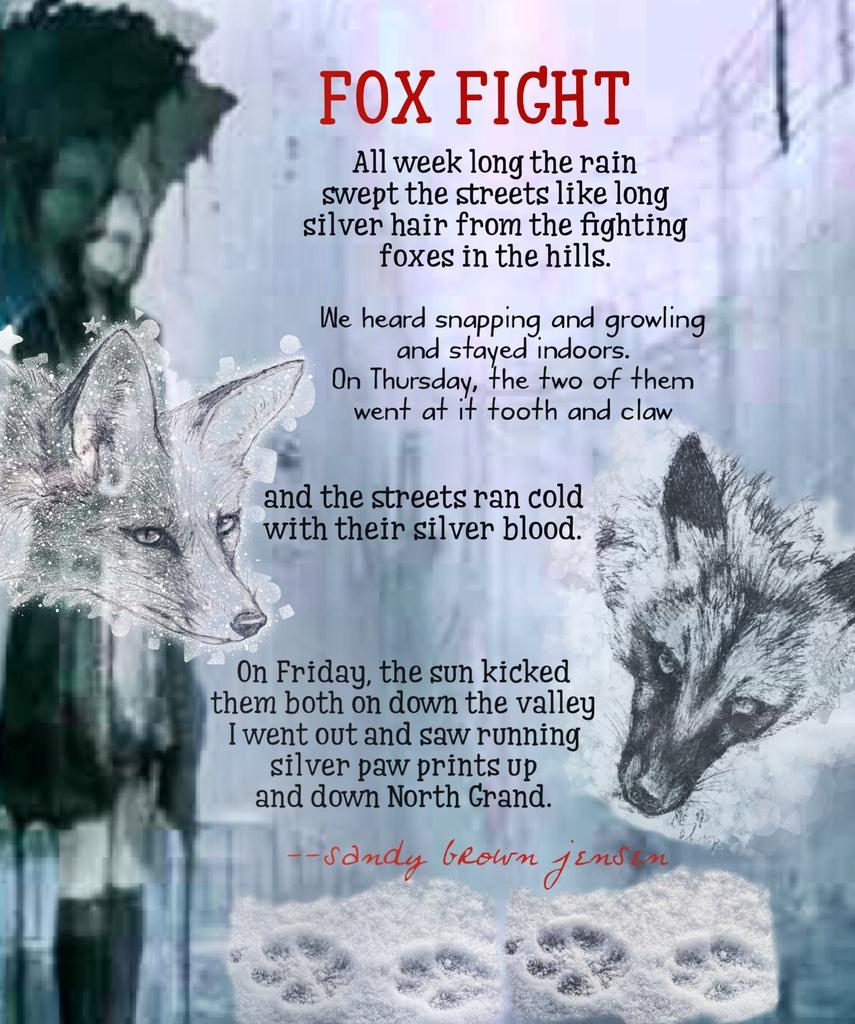What is featured on the poster in the image? There is a poster in the image, and it contains two animals. What else can be seen on the poster besides the animals? There is text present on the poster. How much payment is required to trade for the animals depicted on the poster? There is no mention of payment or trade in the image; it only features a poster with two animals and text. 